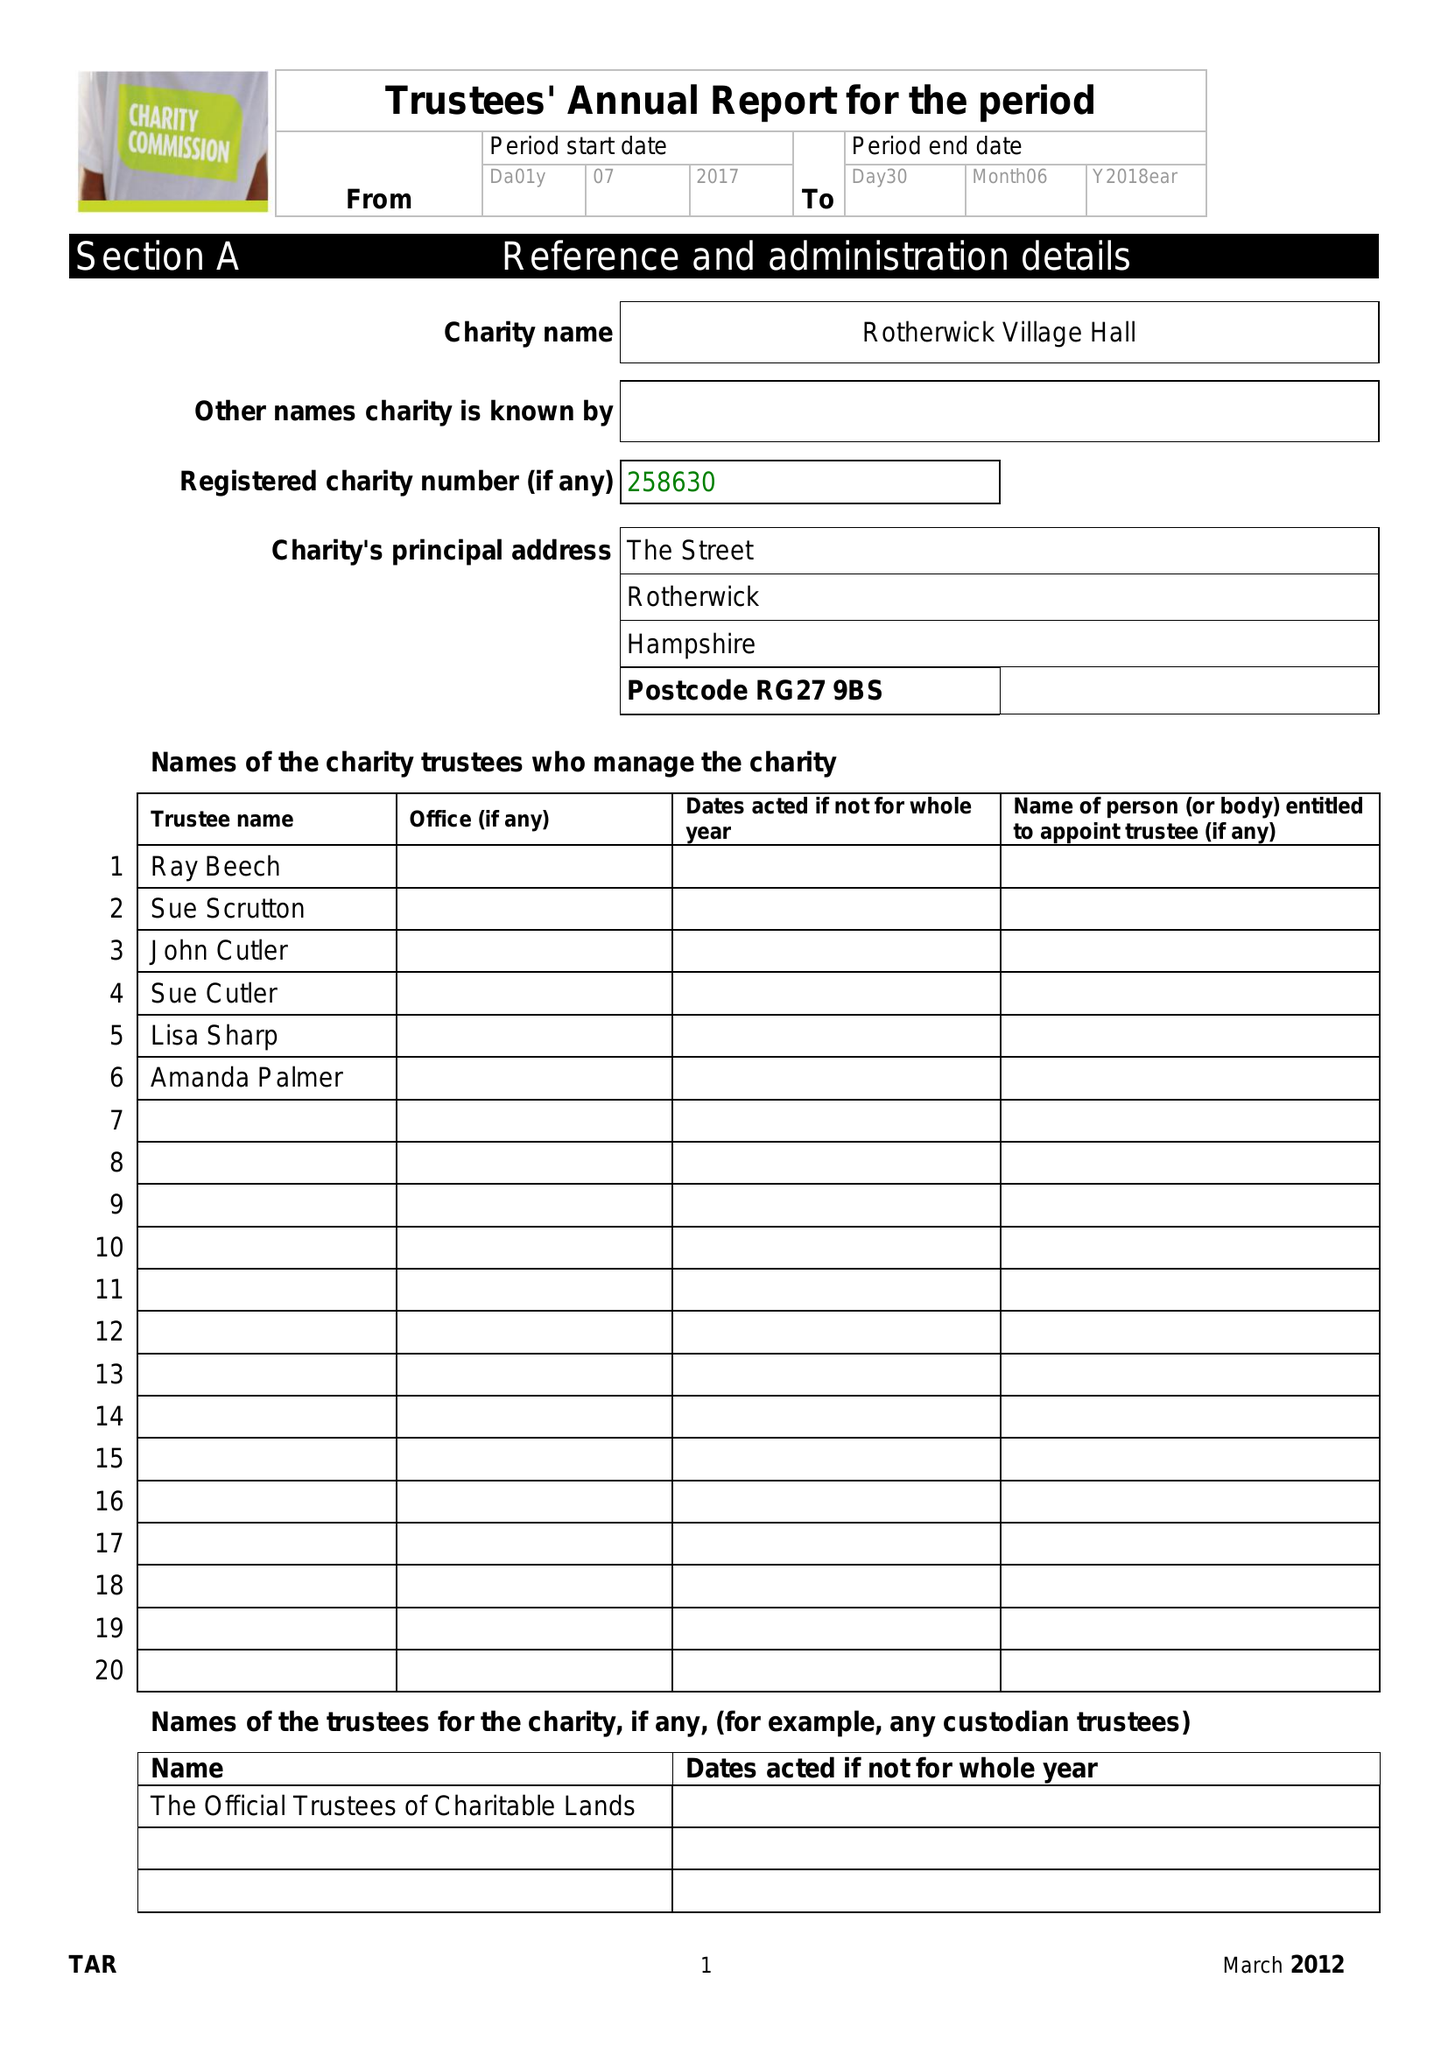What is the value for the charity_number?
Answer the question using a single word or phrase. 258630 